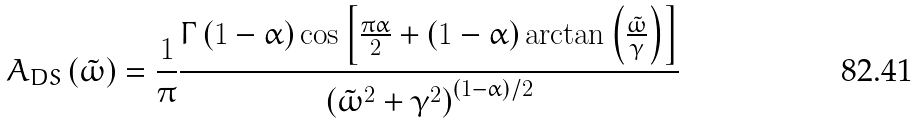<formula> <loc_0><loc_0><loc_500><loc_500>A _ { D S } \left ( \tilde { \omega } \right ) = \frac { 1 } { \pi } \frac { \Gamma \left ( 1 - \alpha \right ) \cos \left [ \frac { \pi \alpha } { 2 } + \left ( 1 - \alpha \right ) \arctan \left ( \frac { \tilde { \omega } } { \gamma } \right ) \right ] } { \left ( \tilde { \omega } ^ { 2 } + \gamma ^ { 2 } \right ) ^ { \left ( 1 - \alpha \right ) / 2 } }</formula> 